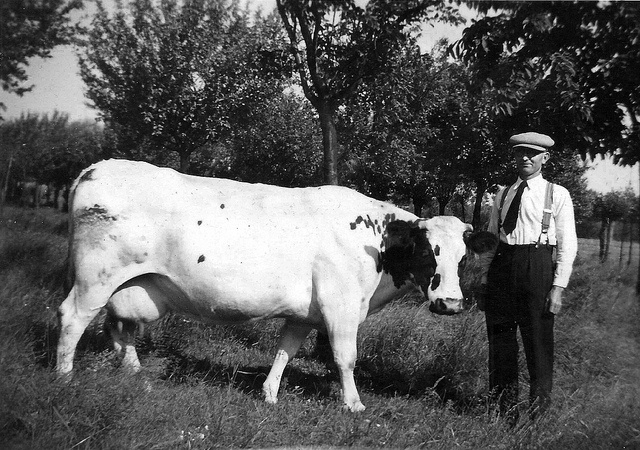Describe the objects in this image and their specific colors. I can see cow in black, white, gray, and darkgray tones, people in black, white, darkgray, and gray tones, and tie in black, gray, darkgray, and white tones in this image. 